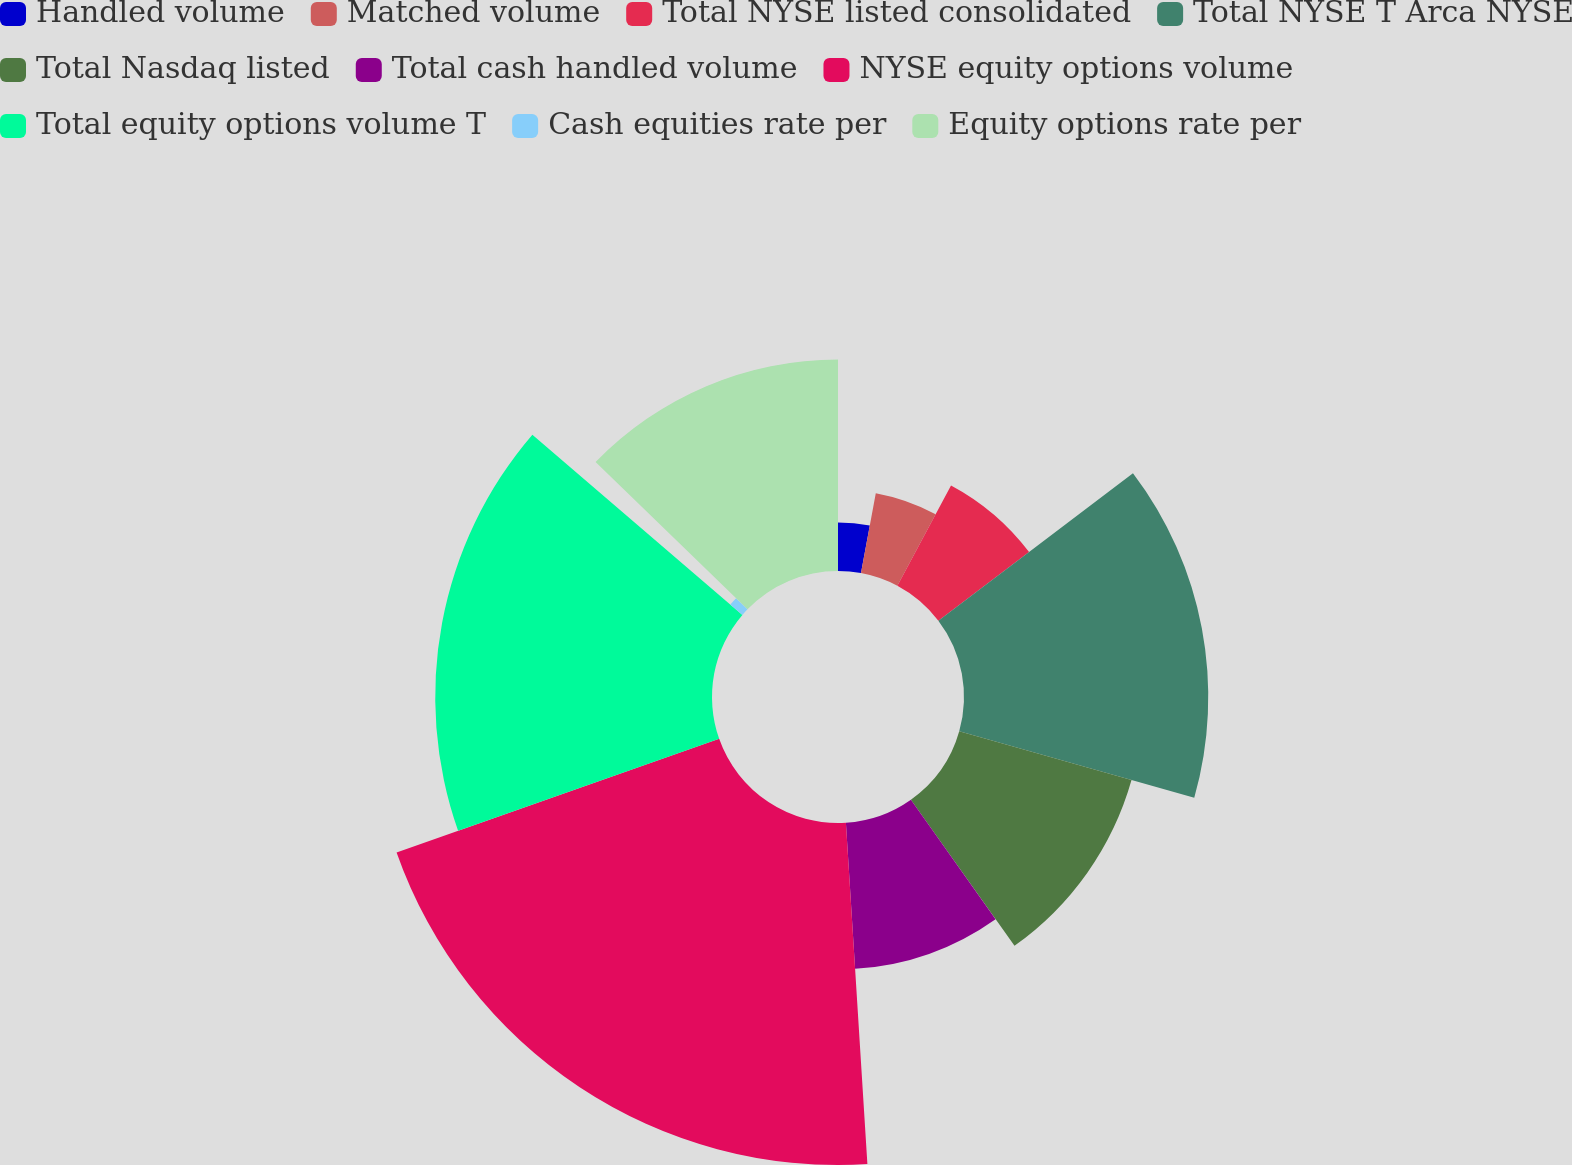Convert chart to OTSL. <chart><loc_0><loc_0><loc_500><loc_500><pie_chart><fcel>Handled volume<fcel>Matched volume<fcel>Total NYSE listed consolidated<fcel>Total NYSE T Arca NYSE<fcel>Total Nasdaq listed<fcel>Total cash handled volume<fcel>NYSE equity options volume<fcel>Total equity options volume T<fcel>Cash equities rate per<fcel>Equity options rate per<nl><fcel>2.92%<fcel>4.89%<fcel>6.86%<fcel>14.72%<fcel>10.79%<fcel>8.82%<fcel>20.61%<fcel>16.68%<fcel>0.96%<fcel>12.75%<nl></chart> 